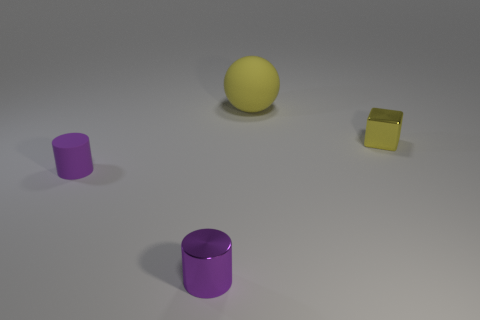There is a tiny shiny thing that is the same shape as the small rubber thing; what color is it?
Ensure brevity in your answer.  Purple. Is there any other thing that has the same shape as the big rubber thing?
Your answer should be very brief. No. The shiny object that is right of the tiny purple metal object has what shape?
Give a very brief answer. Cube. What number of tiny matte objects have the same shape as the large object?
Your answer should be compact. 0. Is the color of the cylinder that is in front of the tiny purple rubber cylinder the same as the matte object that is in front of the big rubber ball?
Provide a short and direct response. Yes. How many things are small purple metallic cylinders or blocks?
Offer a very short reply. 2. How many purple things have the same material as the big yellow thing?
Offer a terse response. 1. Is the number of purple matte cylinders less than the number of tiny things?
Your response must be concise. Yes. Does the small purple cylinder that is in front of the tiny matte thing have the same material as the large ball?
Give a very brief answer. No. What number of blocks are large metal objects or large matte objects?
Offer a terse response. 0. 